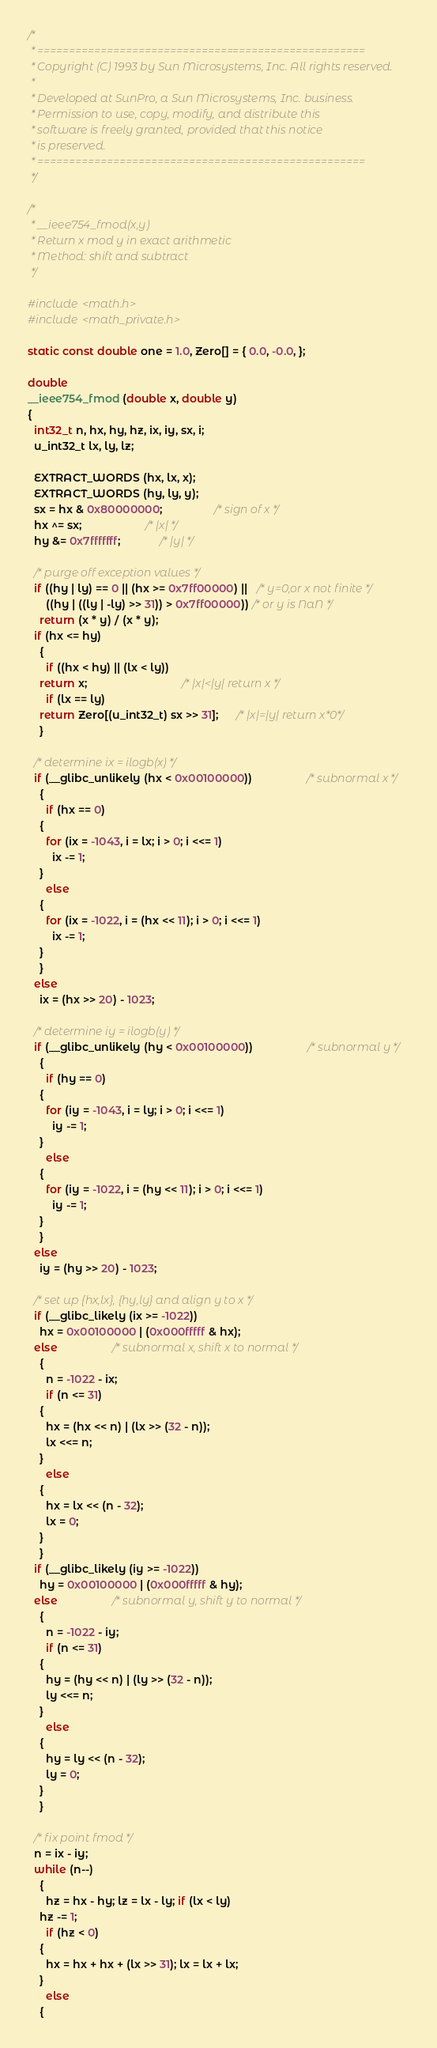<code> <loc_0><loc_0><loc_500><loc_500><_C_>/*
 * ====================================================
 * Copyright (C) 1993 by Sun Microsystems, Inc. All rights reserved.
 *
 * Developed at SunPro, a Sun Microsystems, Inc. business.
 * Permission to use, copy, modify, and distribute this
 * software is freely granted, provided that this notice
 * is preserved.
 * ====================================================
 */

/*
 * __ieee754_fmod(x,y)
 * Return x mod y in exact arithmetic
 * Method: shift and subtract
 */

#include <math.h>
#include <math_private.h>

static const double one = 1.0, Zero[] = { 0.0, -0.0, };

double
__ieee754_fmod (double x, double y)
{
  int32_t n, hx, hy, hz, ix, iy, sx, i;
  u_int32_t lx, ly, lz;

  EXTRACT_WORDS (hx, lx, x);
  EXTRACT_WORDS (hy, ly, y);
  sx = hx & 0x80000000;                 /* sign of x */
  hx ^= sx;                     /* |x| */
  hy &= 0x7fffffff;             /* |y| */

  /* purge off exception values */
  if ((hy | ly) == 0 || (hx >= 0x7ff00000) ||   /* y=0,or x not finite */
      ((hy | ((ly | -ly) >> 31)) > 0x7ff00000)) /* or y is NaN */
    return (x * y) / (x * y);
  if (hx <= hy)
    {
      if ((hx < hy) || (lx < ly))
	return x;                               /* |x|<|y| return x */
      if (lx == ly)
	return Zero[(u_int32_t) sx >> 31];      /* |x|=|y| return x*0*/
    }

  /* determine ix = ilogb(x) */
  if (__glibc_unlikely (hx < 0x00100000))                  /* subnormal x */
    {
      if (hx == 0)
	{
	  for (ix = -1043, i = lx; i > 0; i <<= 1)
	    ix -= 1;
	}
      else
	{
	  for (ix = -1022, i = (hx << 11); i > 0; i <<= 1)
	    ix -= 1;
	}
    }
  else
    ix = (hx >> 20) - 1023;

  /* determine iy = ilogb(y) */
  if (__glibc_unlikely (hy < 0x00100000))                  /* subnormal y */
    {
      if (hy == 0)
	{
	  for (iy = -1043, i = ly; i > 0; i <<= 1)
	    iy -= 1;
	}
      else
	{
	  for (iy = -1022, i = (hy << 11); i > 0; i <<= 1)
	    iy -= 1;
	}
    }
  else
    iy = (hy >> 20) - 1023;

  /* set up {hx,lx}, {hy,ly} and align y to x */
  if (__glibc_likely (ix >= -1022))
    hx = 0x00100000 | (0x000fffff & hx);
  else                  /* subnormal x, shift x to normal */
    {
      n = -1022 - ix;
      if (n <= 31)
	{
	  hx = (hx << n) | (lx >> (32 - n));
	  lx <<= n;
	}
      else
	{
	  hx = lx << (n - 32);
	  lx = 0;
	}
    }
  if (__glibc_likely (iy >= -1022))
    hy = 0x00100000 | (0x000fffff & hy);
  else                  /* subnormal y, shift y to normal */
    {
      n = -1022 - iy;
      if (n <= 31)
	{
	  hy = (hy << n) | (ly >> (32 - n));
	  ly <<= n;
	}
      else
	{
	  hy = ly << (n - 32);
	  ly = 0;
	}
    }

  /* fix point fmod */
  n = ix - iy;
  while (n--)
    {
      hz = hx - hy; lz = lx - ly; if (lx < ly)
	hz -= 1;
      if (hz < 0)
	{
	  hx = hx + hx + (lx >> 31); lx = lx + lx;
	}
      else
	{</code> 